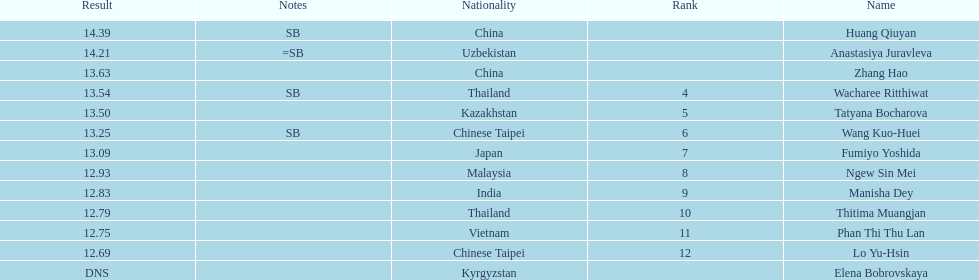How many contestants were from thailand? 2. 